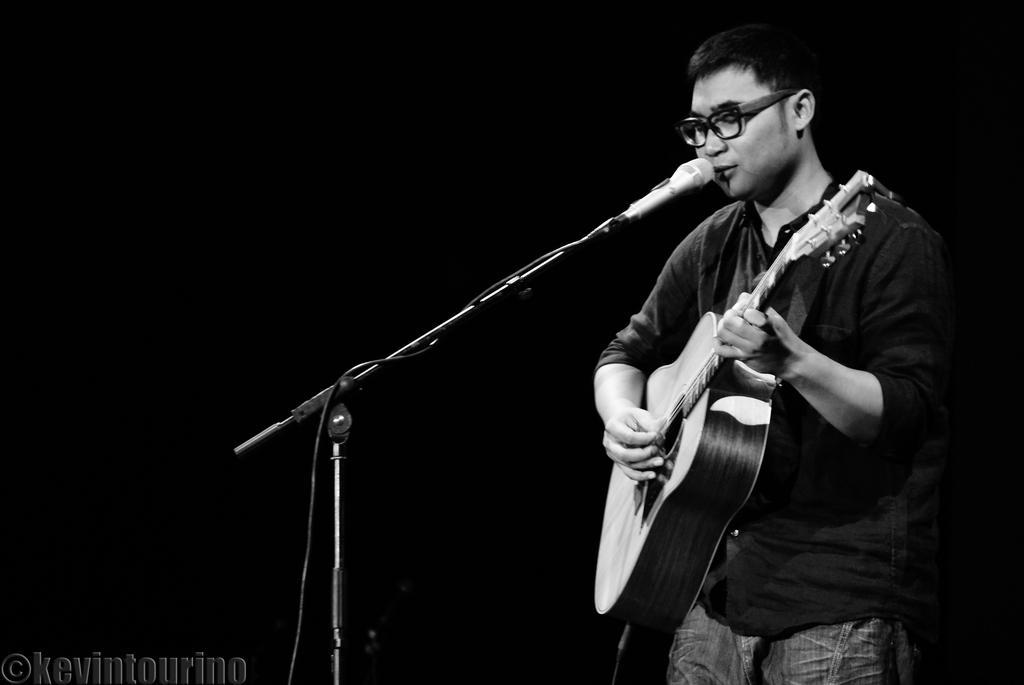Describe this image in one or two sentences. In this image a person is standing and holding a guitar and he is playing guitar. There is a mike stand before this person. There is a watermark written at the left bottom corner as kevintourino. 